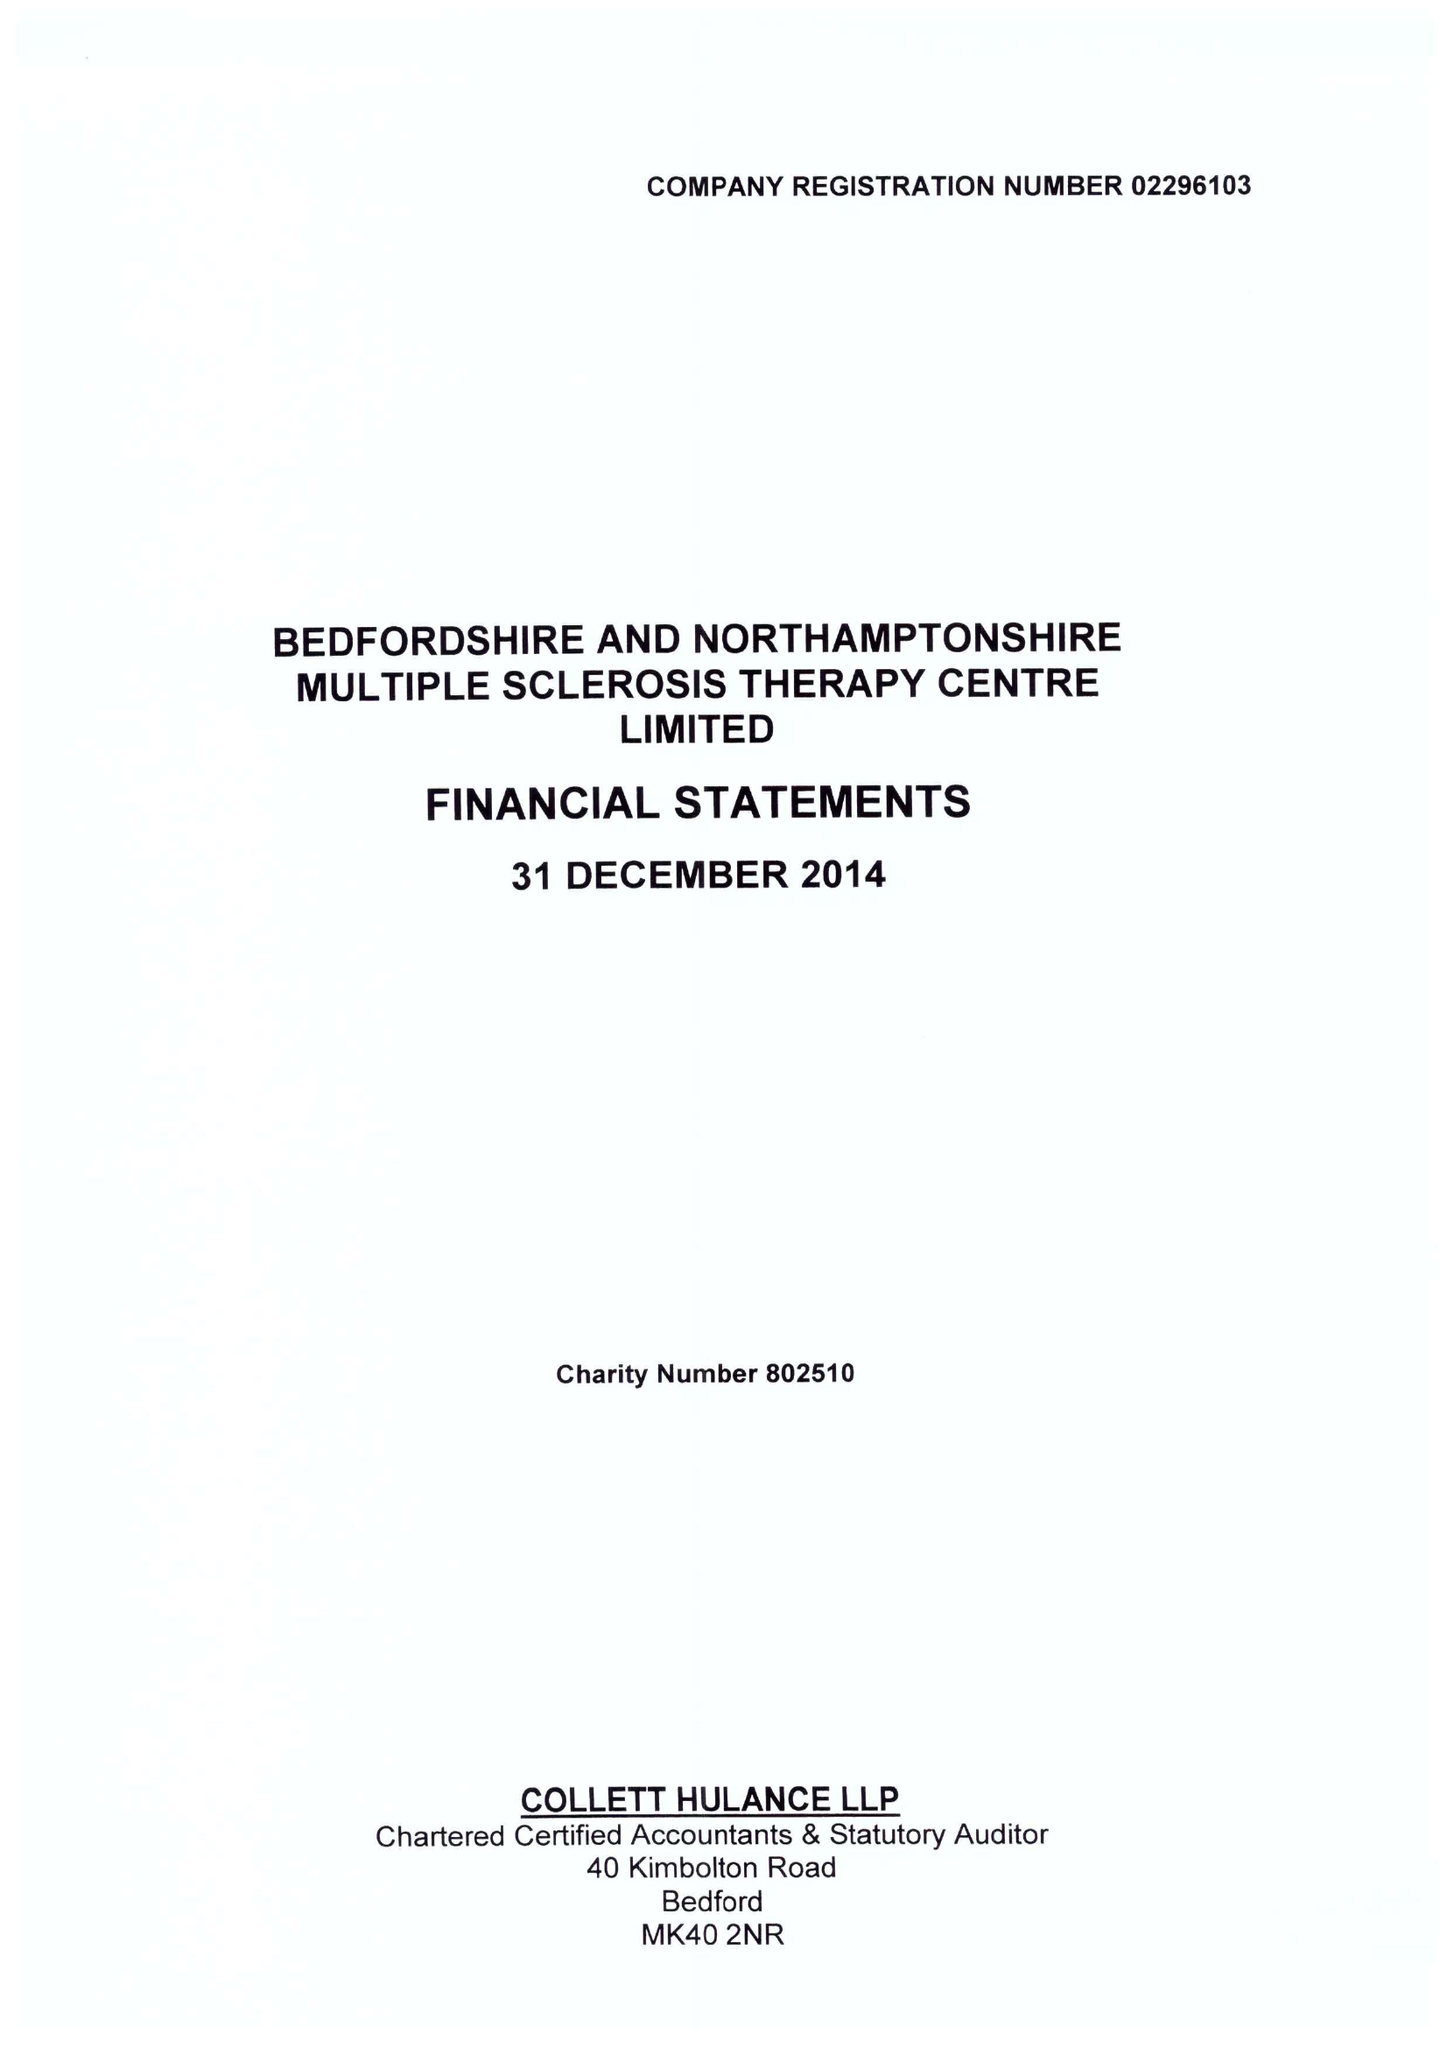What is the value for the charity_number?
Answer the question using a single word or phrase. 802510 